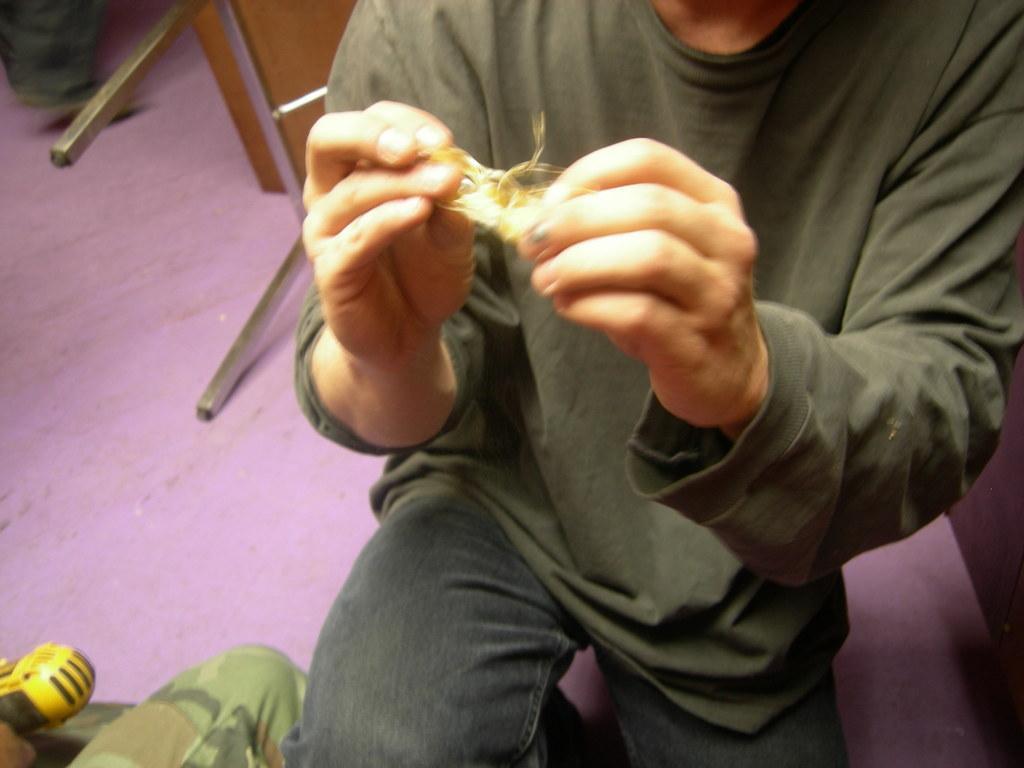Could you give a brief overview of what you see in this image? In this picture we can see a person in the squat position and the person is holding an item. On the left side of the person there is a yellow object and behind the person there are steel rods and other things on the floor. 